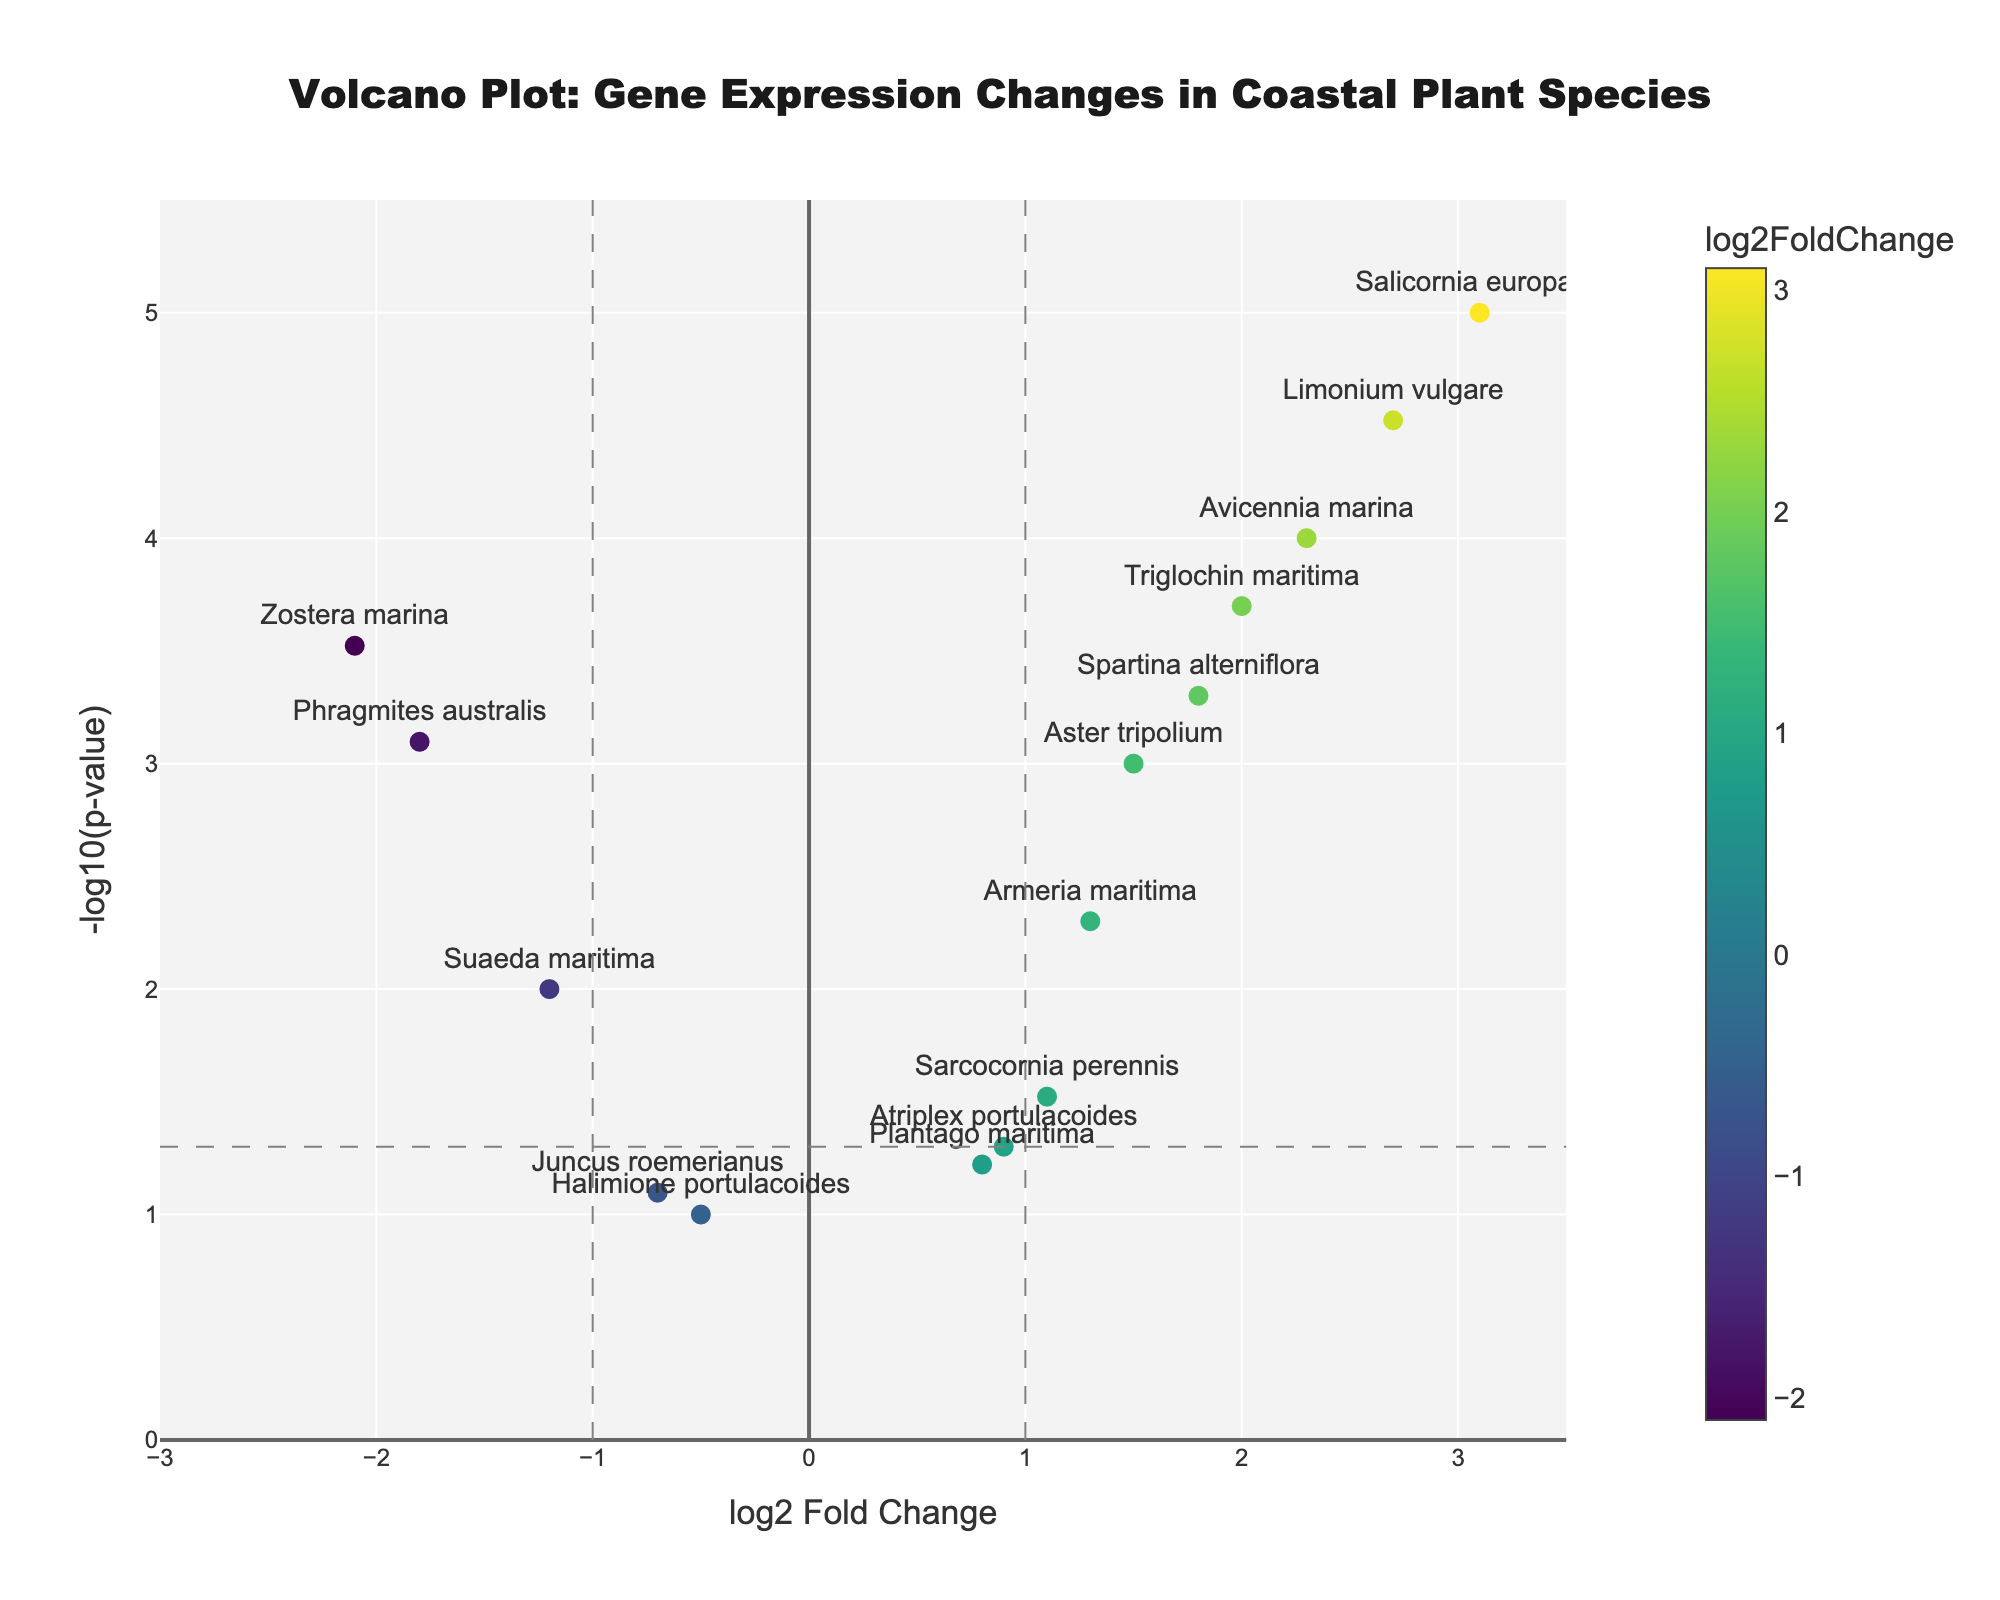What does the title of the plot indicate? The title of the plot is "Volcano Plot: Gene Expression Changes in Coastal Plant Species," and it indicates that the plot visualizes how gene expression in coastal plant species changes with increased salinity. This is shown using a volcano plot format.
Answer: Gene expression changes in coastal plant species What do the axes represent? The x-axis represents the log2 Fold Change, which indicates the ratio of gene expression changes, while the y-axis represents -log10(p-value), which indicates the statistical significance of those changes.
Answer: log2 Fold Change and -log10(p-value) Which gene shows the highest fold change? To find the highest fold change, we look for the gene with the highest value on the x-axis. "Salicornia europaea" has the highest log2 Fold Change of 3.1.
Answer: Salicornia europaea How many genes have statistically significant changes below the p-value threshold of 0.05? Genes with statistically significant changes fall above the horizontal dashed line representing -log10(0.05). By counting these points, we can identify 9 genes.
Answer: 9 Which gene has the lowest p-value and what does it signify about its expression change? A lower p-value corresponds to a higher value on the y-axis. "Salicornia europaea" with a -log10(p-value) of 5 indicates it has the lowest p-value, signifying a very statistically significant change in expression.
Answer: Salicornia europaea How does the expression of "Phragmites australis" compare to "Avicennia marina"? "Phragmites australis" has a log2 Fold Change of -1.8 and a statistically significant change (high y-position), indicating downregulation. "Avicennia marina" has a log2 Fold Change of 2.3, indicating upregulation. Thus, "Avicennia marina" is upregulated, whereas "Phragmites australis" is downregulated.
Answer: "Avicennia marina" is upregulated, "Phragmites australis" is downregulated Are there any genes that are downregulated but not statistically significant? If so, which ones? Downregulated genes have negative log2 Fold Change values, and non-significant genes fall below the horizontal dashed line. "Halimione portulacoides" and "Juncus roemerianus" are downregulated but not statistically significant.
Answer: Halimione portulacoides, Juncus roemerianus Which genes are plotted furthest to the left and right on the plot, and what does this imply about their gene expression? The gene furthest to the left is "Zostera marina" with a log2 Fold Change of -2.1, indicating significant downregulation. The gene furthest to the right is "Salicornia europaea" with a log2 Fold Change of 3.1, indicating significant upregulation.
Answer: "Zostera marina" and "Salicornia europaea" How do we interpret the color scale on the plot? The color scale represents the log2 Fold Change values, with different shades indicating the degree of change. Lighter colors indicate higher fold changes.
Answer: Degree of log2 Fold Change 